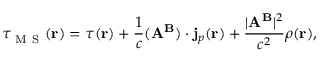Convert formula to latex. <formula><loc_0><loc_0><loc_500><loc_500>\tau _ { M S } ( r ) = \tau ( r ) + \frac { 1 } { c } ( A ^ { B } ) \cdot j _ { p } ( r ) + \frac { | A ^ { B } | ^ { 2 } } { c ^ { 2 } } \rho ( r ) ,</formula> 